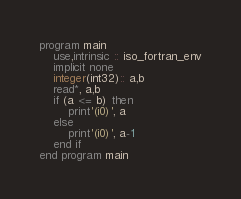Convert code to text. <code><loc_0><loc_0><loc_500><loc_500><_FORTRAN_>program main
    use,intrinsic :: iso_fortran_env
    implicit none
    integer(int32):: a,b
    read*, a,b
    if (a <= b) then
        print'(i0)', a
    else
        print'(i0)', a-1
    end if
end program main</code> 